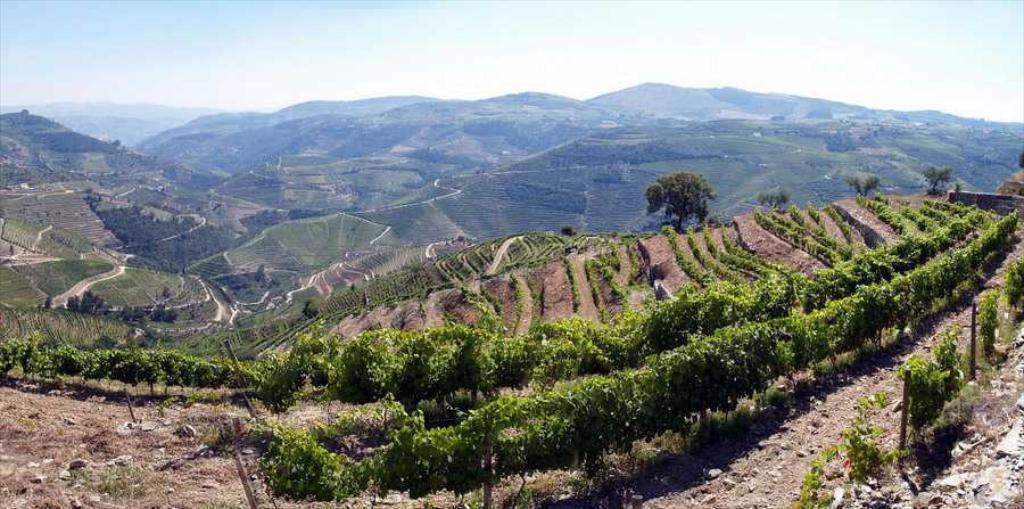Describe this image in one or two sentences. Here in this picture we can see mountains covered all over the place and we can see plants, trees and grass on the mountains, which are covered all over there. 